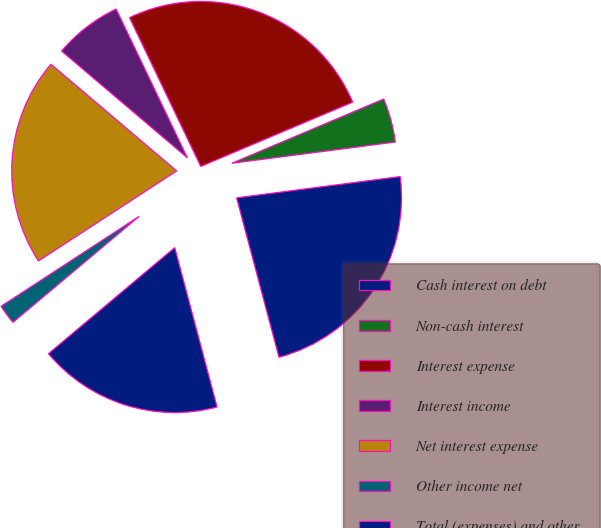<chart> <loc_0><loc_0><loc_500><loc_500><pie_chart><fcel>Cash interest on debt<fcel>Non-cash interest<fcel>Interest expense<fcel>Interest income<fcel>Net interest expense<fcel>Other income net<fcel>Total (expenses) and other<nl><fcel>22.92%<fcel>4.31%<fcel>25.73%<fcel>6.69%<fcel>20.39%<fcel>1.93%<fcel>18.01%<nl></chart> 